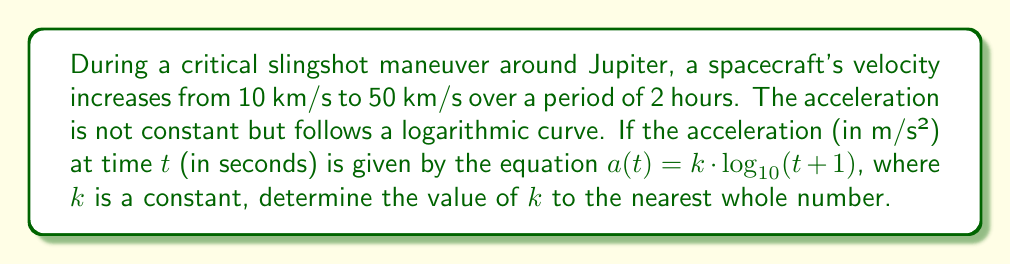Can you solve this math problem? To solve this problem, we'll follow these steps:

1) First, let's convert the given velocities to m/s:
   Initial velocity, $v_0 = 10$ km/s = $10,000$ m/s
   Final velocity, $v_f = 50$ km/s = $50,000$ m/s

2) The time period is 2 hours, which is 7200 seconds.

3) The change in velocity is:
   $\Delta v = v_f - v_0 = 50,000 - 10,000 = 40,000$ m/s

4) We know that acceleration is the rate of change of velocity. In this case, we're given that the acceleration follows a logarithmic curve:

   $a(t) = k \cdot \log_{10}(t+1)$

5) To find the total change in velocity, we need to integrate this acceleration over the time period:

   $\Delta v = \int_0^{7200} k \cdot \log_{10}(t+1) dt$

6) Solving this integral:

   $\Delta v = k \cdot \left[ (t+1)\log_{10}(t+1) - \frac{t+1}{\ln(10)} \right]_0^{7200}$

7) Evaluating at the limits:

   $40,000 = k \cdot \left[ (7201)\log_{10}(7201) - \frac{7201}{\ln(10)} - (1)\log_{10}(1) + \frac{1}{\ln(10)} \right]$

8) Simplifying:

   $40,000 = k \cdot \left[ 28,804 - 3,126 + 0.434 \right] = k \cdot 25,678.434$

9) Solving for k:

   $k = \frac{40,000}{25,678.434} \approx 1.557$

10) Rounding to the nearest whole number:

    $k \approx 2$
Answer: $k \approx 2$ 